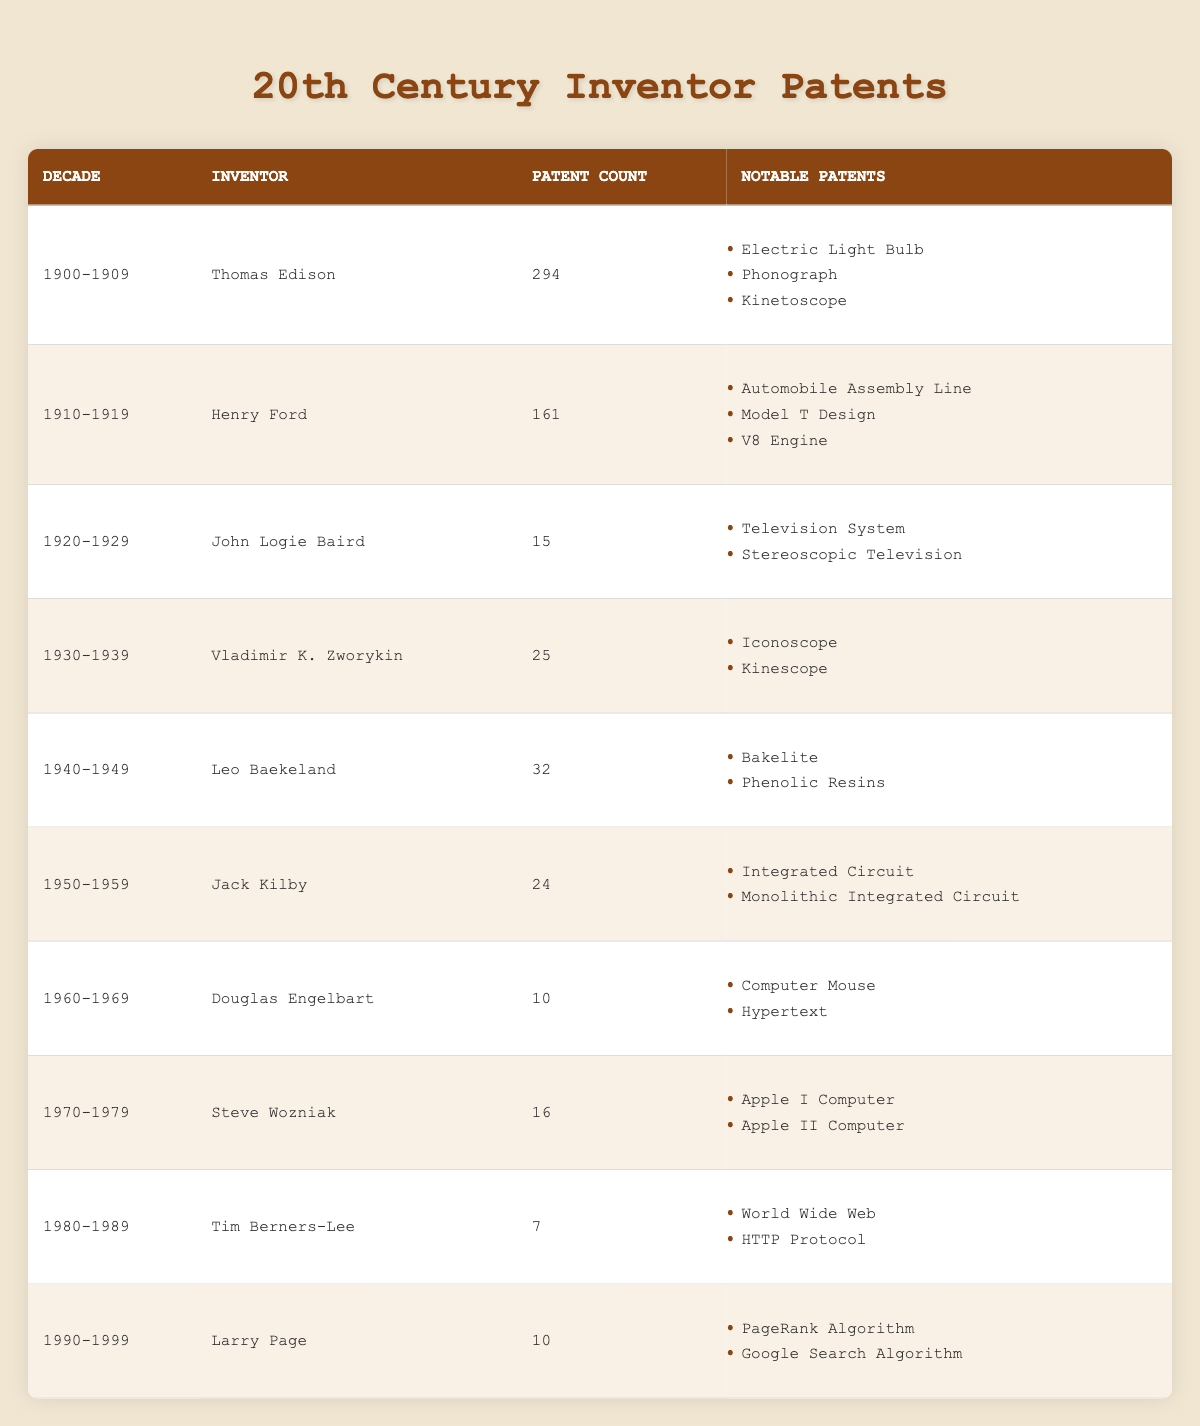What decade had the highest number of patents filed by an inventor? The table shows that Thomas Edison filed the highest number of patents (294) in the decade 1900-1909, which is greater than any other inventor's count.
Answer: 1900-1909 Which inventor filed the fewest patents, and in what decade? John Logie Baird filed the fewest patents (15) in the decade 1920-1929. This information can be directly found in the table under "patent count."
Answer: John Logie Baird, 1920-1929 How many total patents were filed by inventors between 1940 and 1949? To find the total patents for the decade 1940-1949, we can refer to the table where Leo Baekeland filed 32 patents. Since this is the only entry for that decade, the total is 32.
Answer: 32 Did any inventor file patents in every decade of the 20th century? By examining the table, it is clear that no inventor appears in every decade; the table lists distinct inventors for each decade without repetition.
Answer: No What is the difference in patent counts between the decades of 1910-1919 and 1950-1959? First, we find the patent counts: Henry Ford filed 161 patents in 1910-1919, while Jack Kilby filed 24 patents in 1950-1959. The difference is 161 - 24 = 137.
Answer: 137 Who invented the Integrated Circuit, and how many patents did this inventor file? The table indicates that Jack Kilby invented the Integrated Circuit and filed a total of 24 patents during the decade of 1950-1959.
Answer: Jack Kilby, 24 What notable patent was filed by Steve Wozniak? From the table, one of the notable patents filed by Steve Wozniak is the Apple I Computer, which is specifically listed under his entry for the decade 1970-1979.
Answer: Apple I Computer How many inventors filed patents in the decade 1980-1989? The table shows that only Tim Berners-Lee is listed as an inventor for the decade 1980-1989, indicating that there is only one inventor for that decade.
Answer: 1 